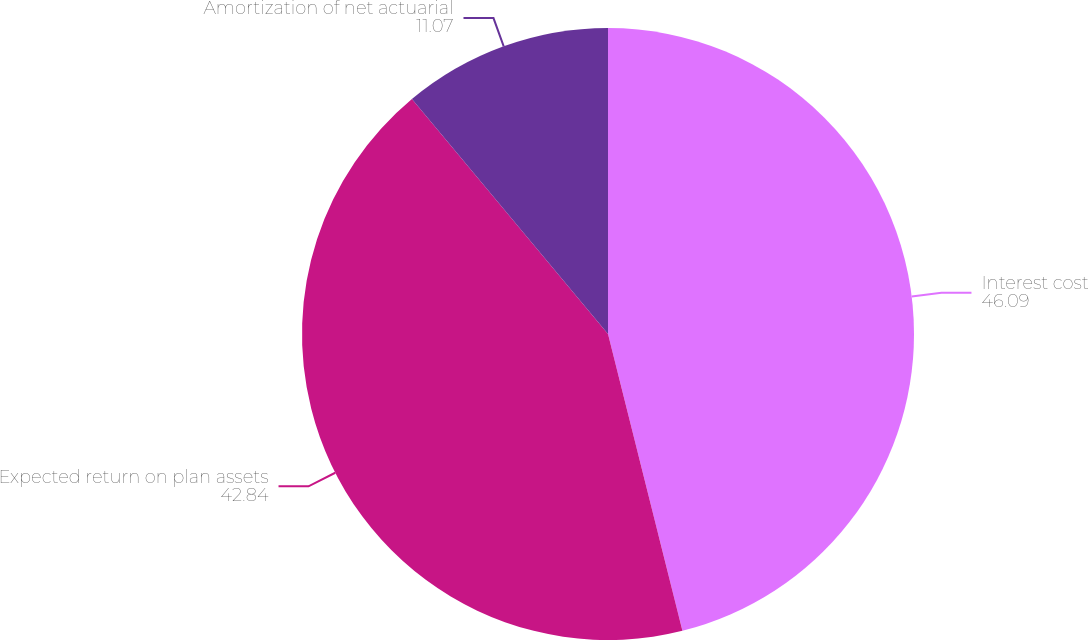Convert chart to OTSL. <chart><loc_0><loc_0><loc_500><loc_500><pie_chart><fcel>Interest cost<fcel>Expected return on plan assets<fcel>Amortization of net actuarial<nl><fcel>46.09%<fcel>42.84%<fcel>11.07%<nl></chart> 